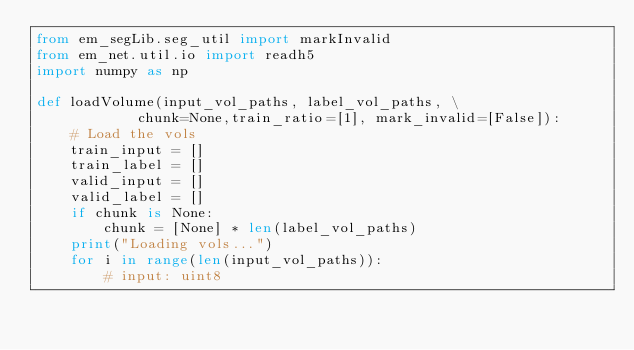<code> <loc_0><loc_0><loc_500><loc_500><_Python_>from em_segLib.seg_util import markInvalid
from em_net.util.io import readh5
import numpy as np

def loadVolume(input_vol_paths, label_vol_paths, \
            chunk=None,train_ratio=[1], mark_invalid=[False]):
    # Load the vols
    train_input = []
    train_label = []
    valid_input = []
    valid_label = []
    if chunk is None:
        chunk = [None] * len(label_vol_paths)
    print("Loading vols...")
    for i in range(len(input_vol_paths)):
        # input: uint8</code> 